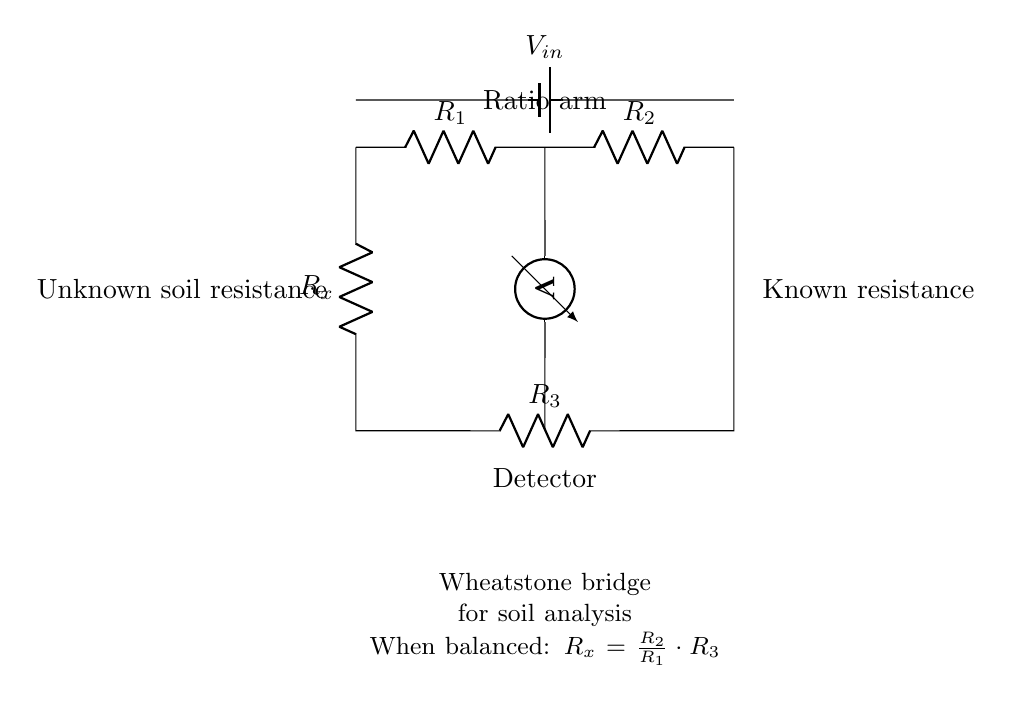What is the value of the unknown resistance? The unknown resistance is represented as R_x in the circuit. It is calculated using the formula when the bridge is balanced: R_x = (R_2 / R_1) * R_3. The circuit does not provide specific values, so R_x remains a variable.
Answer: R_x What components are connected in series? In the Wheatstone bridge, R_1 and R_2 are in series on the top branch, while R_x and R_3 are in series on the bottom branch. Series connections typically influence the total resistance and voltage drop across the circuit.
Answer: R_1, R_2, R_x, R_3 What is the role of the voltmeter in this circuit? The voltmeter in the circuit measures the voltage difference between the two points where it is connected, which helps determine if the bridge is balanced. A balanced bridge indicates that the ratio of the resistances is equal.
Answer: Measure voltage difference How is the Wheatstone bridge balanced? The bridge is balanced when the ratio of R_2 to R_1 is equal to the ratio of R_x to R_3. When this condition is met, the voltage across the voltmeter becomes zero, indicating no potential difference and a balanced state.
Answer: R_2 / R_1 = R_x / R_3 What is the significance of the battery in this circuit? The battery provides a constant voltage supply (V_in) necessary for the operation of the Wheatstone bridge. It creates the potential difference that drives current through the resistances, allowing for measurements by the voltmeter.
Answer: Provides voltage supply What does the formula in the annotation represent? The formula describes the relationship among the resistances when the bridge is balanced. Specifically, it shows how to calculate the unknown resistance R_x based on the known resistances R_1, R_2, and R_3, which is essential for precise measurements in soil analysis.
Answer: Calculate unknown resistance 